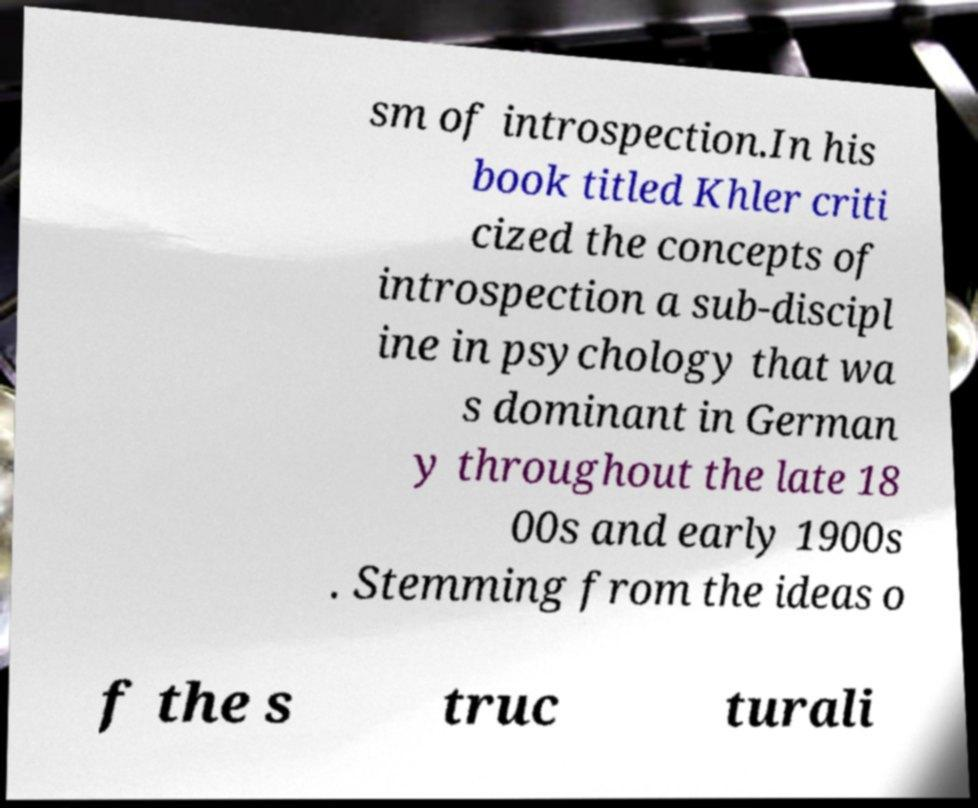Could you assist in decoding the text presented in this image and type it out clearly? sm of introspection.In his book titled Khler criti cized the concepts of introspection a sub-discipl ine in psychology that wa s dominant in German y throughout the late 18 00s and early 1900s . Stemming from the ideas o f the s truc turali 